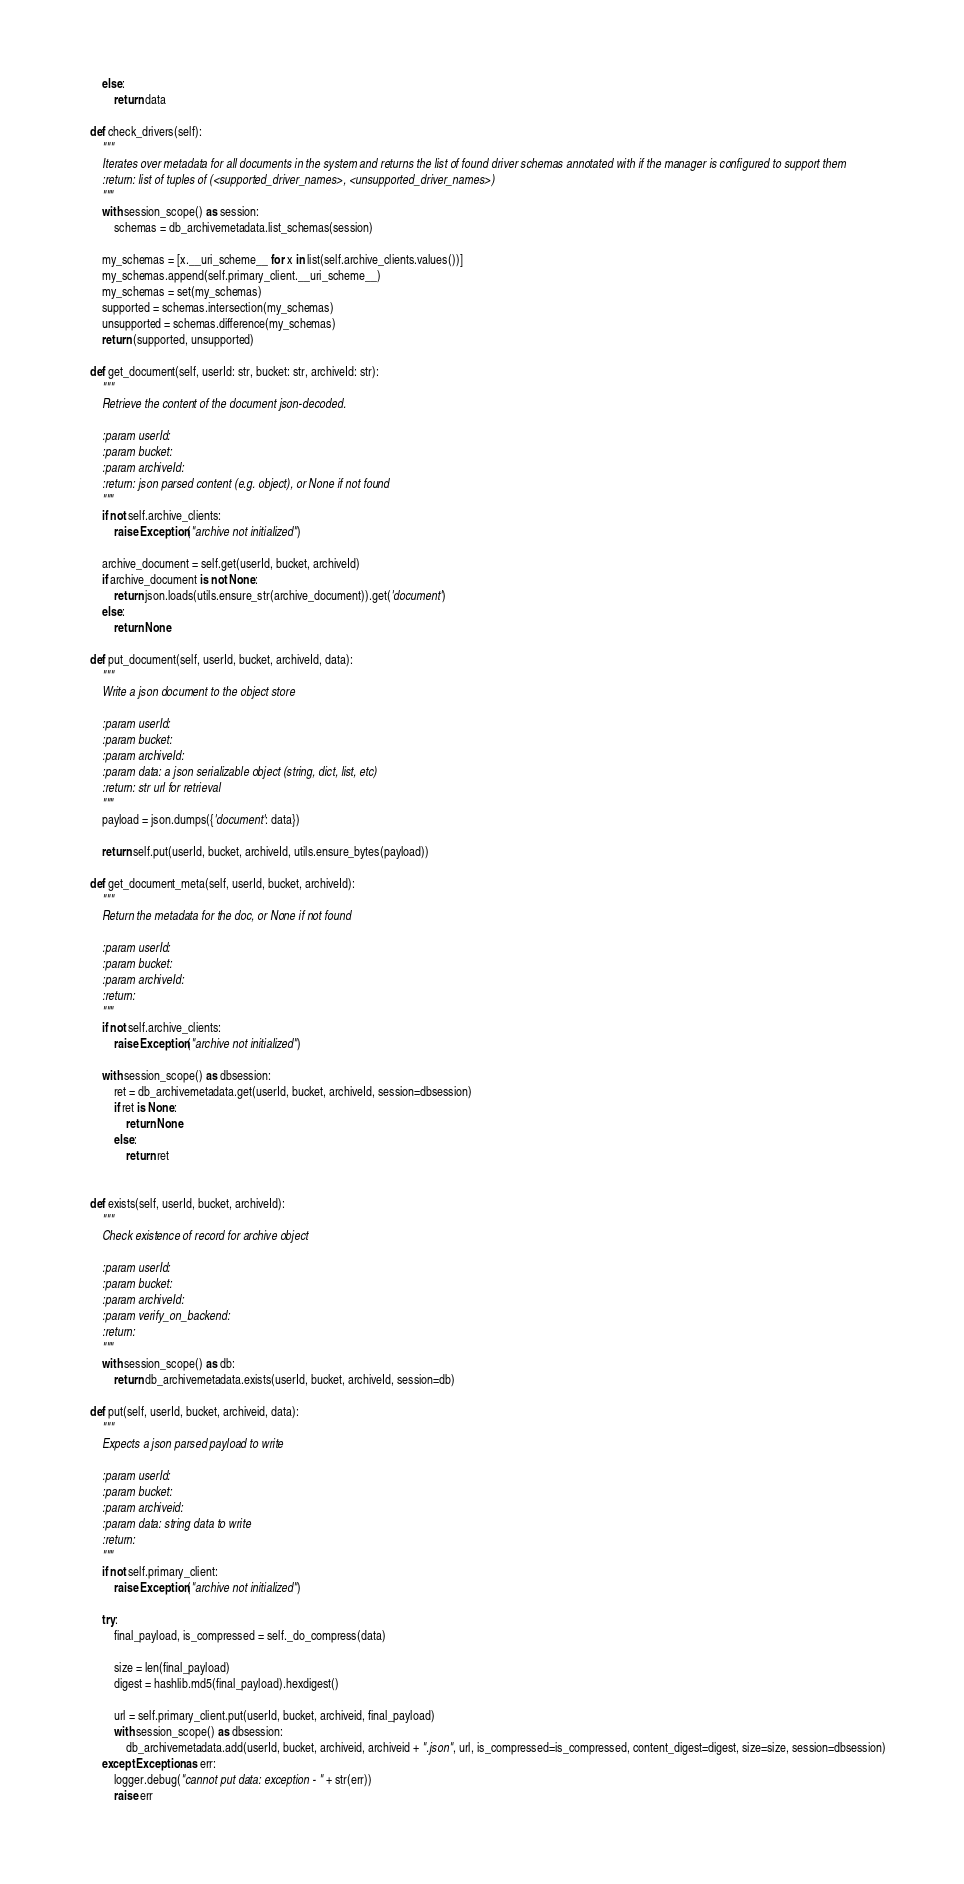Convert code to text. <code><loc_0><loc_0><loc_500><loc_500><_Python_>        else:
            return data

    def check_drivers(self):
        """
        Iterates over metadata for all documents in the system and returns the list of found driver schemas annotated with if the manager is configured to support them
        :return: list of tuples of (<supported_driver_names>, <unsupported_driver_names>)
        """
        with session_scope() as session:
            schemas = db_archivemetadata.list_schemas(session)

        my_schemas = [x.__uri_scheme__ for x in list(self.archive_clients.values())]
        my_schemas.append(self.primary_client.__uri_scheme__)
        my_schemas = set(my_schemas)
        supported = schemas.intersection(my_schemas)
        unsupported = schemas.difference(my_schemas)
        return (supported, unsupported)

    def get_document(self, userId: str, bucket: str, archiveId: str):
        """
        Retrieve the content of the document json-decoded.

        :param userId:
        :param bucket:
        :param archiveId:
        :return: json parsed content (e.g. object), or None if not found
        """
        if not self.archive_clients:
            raise Exception("archive not initialized")

        archive_document = self.get(userId, bucket, archiveId)
        if archive_document is not None:
            return json.loads(utils.ensure_str(archive_document)).get('document')
        else:
            return None

    def put_document(self, userId, bucket, archiveId, data):
        """
        Write a json document to the object store

        :param userId:
        :param bucket:
        :param archiveId:
        :param data: a json serializable object (string, dict, list, etc)
        :return: str url for retrieval
        """
        payload = json.dumps({'document': data})

        return self.put(userId, bucket, archiveId, utils.ensure_bytes(payload))

    def get_document_meta(self, userId, bucket, archiveId):
        """
        Return the metadata for the doc, or None if not found

        :param userId:
        :param bucket:
        :param archiveId:
        :return:
        """
        if not self.archive_clients:
            raise Exception("archive not initialized")

        with session_scope() as dbsession:
            ret = db_archivemetadata.get(userId, bucket, archiveId, session=dbsession)
            if ret is None:
                return None
            else:
                return ret


    def exists(self, userId, bucket, archiveId):
        """
        Check existence of record for archive object

        :param userId:
        :param bucket:
        :param archiveId:
        :param verify_on_backend:
        :return:
        """
        with session_scope() as db:
            return db_archivemetadata.exists(userId, bucket, archiveId, session=db)

    def put(self, userId, bucket, archiveid, data):
        """
        Expects a json parsed payload to write

        :param userId:
        :param bucket:
        :param archiveid:
        :param data: string data to write
        :return:
        """
        if not self.primary_client:
            raise Exception("archive not initialized")

        try:
            final_payload, is_compressed = self._do_compress(data)

            size = len(final_payload)
            digest = hashlib.md5(final_payload).hexdigest()

            url = self.primary_client.put(userId, bucket, archiveid, final_payload)
            with session_scope() as dbsession:
                db_archivemetadata.add(userId, bucket, archiveid, archiveid + ".json", url, is_compressed=is_compressed, content_digest=digest, size=size, session=dbsession)
        except Exception as err:
            logger.debug("cannot put data: exception - " + str(err))
            raise err
</code> 